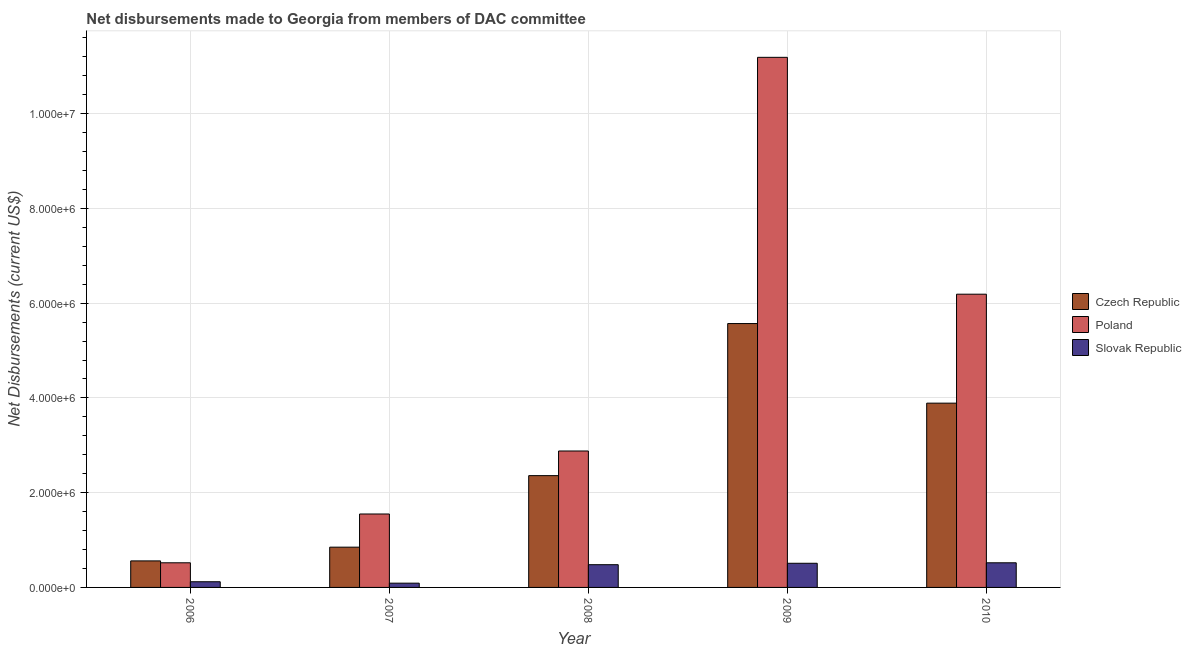How many bars are there on the 2nd tick from the left?
Keep it short and to the point. 3. What is the label of the 2nd group of bars from the left?
Keep it short and to the point. 2007. In how many cases, is the number of bars for a given year not equal to the number of legend labels?
Your answer should be compact. 0. What is the net disbursements made by poland in 2010?
Keep it short and to the point. 6.19e+06. Across all years, what is the maximum net disbursements made by czech republic?
Offer a terse response. 5.57e+06. Across all years, what is the minimum net disbursements made by poland?
Keep it short and to the point. 5.20e+05. What is the total net disbursements made by poland in the graph?
Provide a short and direct response. 2.23e+07. What is the difference between the net disbursements made by slovak republic in 2007 and that in 2009?
Keep it short and to the point. -4.20e+05. What is the difference between the net disbursements made by poland in 2006 and the net disbursements made by slovak republic in 2009?
Ensure brevity in your answer.  -1.07e+07. What is the average net disbursements made by poland per year?
Ensure brevity in your answer.  4.47e+06. In how many years, is the net disbursements made by poland greater than 2400000 US$?
Provide a succinct answer. 3. What is the ratio of the net disbursements made by poland in 2008 to that in 2010?
Give a very brief answer. 0.47. Is the net disbursements made by poland in 2006 less than that in 2010?
Offer a terse response. Yes. What is the difference between the highest and the second highest net disbursements made by czech republic?
Keep it short and to the point. 1.68e+06. What is the difference between the highest and the lowest net disbursements made by czech republic?
Your answer should be compact. 5.01e+06. What does the 3rd bar from the right in 2008 represents?
Provide a short and direct response. Czech Republic. Is it the case that in every year, the sum of the net disbursements made by czech republic and net disbursements made by poland is greater than the net disbursements made by slovak republic?
Your response must be concise. Yes. How many bars are there?
Provide a short and direct response. 15. What is the difference between two consecutive major ticks on the Y-axis?
Ensure brevity in your answer.  2.00e+06. Are the values on the major ticks of Y-axis written in scientific E-notation?
Provide a succinct answer. Yes. Does the graph contain any zero values?
Provide a short and direct response. No. Does the graph contain grids?
Offer a very short reply. Yes. Where does the legend appear in the graph?
Ensure brevity in your answer.  Center right. How many legend labels are there?
Make the answer very short. 3. How are the legend labels stacked?
Offer a terse response. Vertical. What is the title of the graph?
Give a very brief answer. Net disbursements made to Georgia from members of DAC committee. Does "Errors" appear as one of the legend labels in the graph?
Your answer should be very brief. No. What is the label or title of the X-axis?
Keep it short and to the point. Year. What is the label or title of the Y-axis?
Offer a very short reply. Net Disbursements (current US$). What is the Net Disbursements (current US$) of Czech Republic in 2006?
Provide a short and direct response. 5.60e+05. What is the Net Disbursements (current US$) of Poland in 2006?
Give a very brief answer. 5.20e+05. What is the Net Disbursements (current US$) in Slovak Republic in 2006?
Offer a terse response. 1.20e+05. What is the Net Disbursements (current US$) in Czech Republic in 2007?
Provide a succinct answer. 8.50e+05. What is the Net Disbursements (current US$) of Poland in 2007?
Offer a very short reply. 1.55e+06. What is the Net Disbursements (current US$) of Czech Republic in 2008?
Your response must be concise. 2.36e+06. What is the Net Disbursements (current US$) of Poland in 2008?
Provide a succinct answer. 2.88e+06. What is the Net Disbursements (current US$) of Czech Republic in 2009?
Your answer should be compact. 5.57e+06. What is the Net Disbursements (current US$) in Poland in 2009?
Keep it short and to the point. 1.12e+07. What is the Net Disbursements (current US$) of Slovak Republic in 2009?
Give a very brief answer. 5.10e+05. What is the Net Disbursements (current US$) in Czech Republic in 2010?
Give a very brief answer. 3.89e+06. What is the Net Disbursements (current US$) of Poland in 2010?
Give a very brief answer. 6.19e+06. What is the Net Disbursements (current US$) in Slovak Republic in 2010?
Make the answer very short. 5.20e+05. Across all years, what is the maximum Net Disbursements (current US$) of Czech Republic?
Your answer should be compact. 5.57e+06. Across all years, what is the maximum Net Disbursements (current US$) in Poland?
Keep it short and to the point. 1.12e+07. Across all years, what is the maximum Net Disbursements (current US$) in Slovak Republic?
Your answer should be compact. 5.20e+05. Across all years, what is the minimum Net Disbursements (current US$) of Czech Republic?
Offer a very short reply. 5.60e+05. Across all years, what is the minimum Net Disbursements (current US$) in Poland?
Offer a terse response. 5.20e+05. Across all years, what is the minimum Net Disbursements (current US$) of Slovak Republic?
Keep it short and to the point. 9.00e+04. What is the total Net Disbursements (current US$) of Czech Republic in the graph?
Keep it short and to the point. 1.32e+07. What is the total Net Disbursements (current US$) of Poland in the graph?
Offer a terse response. 2.23e+07. What is the total Net Disbursements (current US$) of Slovak Republic in the graph?
Offer a very short reply. 1.72e+06. What is the difference between the Net Disbursements (current US$) of Poland in 2006 and that in 2007?
Your answer should be compact. -1.03e+06. What is the difference between the Net Disbursements (current US$) of Czech Republic in 2006 and that in 2008?
Provide a succinct answer. -1.80e+06. What is the difference between the Net Disbursements (current US$) of Poland in 2006 and that in 2008?
Provide a succinct answer. -2.36e+06. What is the difference between the Net Disbursements (current US$) in Slovak Republic in 2006 and that in 2008?
Provide a succinct answer. -3.60e+05. What is the difference between the Net Disbursements (current US$) of Czech Republic in 2006 and that in 2009?
Your response must be concise. -5.01e+06. What is the difference between the Net Disbursements (current US$) of Poland in 2006 and that in 2009?
Provide a short and direct response. -1.07e+07. What is the difference between the Net Disbursements (current US$) in Slovak Republic in 2006 and that in 2009?
Your answer should be very brief. -3.90e+05. What is the difference between the Net Disbursements (current US$) in Czech Republic in 2006 and that in 2010?
Provide a short and direct response. -3.33e+06. What is the difference between the Net Disbursements (current US$) in Poland in 2006 and that in 2010?
Provide a short and direct response. -5.67e+06. What is the difference between the Net Disbursements (current US$) of Slovak Republic in 2006 and that in 2010?
Offer a very short reply. -4.00e+05. What is the difference between the Net Disbursements (current US$) of Czech Republic in 2007 and that in 2008?
Provide a succinct answer. -1.51e+06. What is the difference between the Net Disbursements (current US$) in Poland in 2007 and that in 2008?
Keep it short and to the point. -1.33e+06. What is the difference between the Net Disbursements (current US$) of Slovak Republic in 2007 and that in 2008?
Your response must be concise. -3.90e+05. What is the difference between the Net Disbursements (current US$) in Czech Republic in 2007 and that in 2009?
Keep it short and to the point. -4.72e+06. What is the difference between the Net Disbursements (current US$) of Poland in 2007 and that in 2009?
Provide a short and direct response. -9.64e+06. What is the difference between the Net Disbursements (current US$) of Slovak Republic in 2007 and that in 2009?
Your answer should be very brief. -4.20e+05. What is the difference between the Net Disbursements (current US$) in Czech Republic in 2007 and that in 2010?
Provide a succinct answer. -3.04e+06. What is the difference between the Net Disbursements (current US$) in Poland in 2007 and that in 2010?
Offer a terse response. -4.64e+06. What is the difference between the Net Disbursements (current US$) in Slovak Republic in 2007 and that in 2010?
Provide a short and direct response. -4.30e+05. What is the difference between the Net Disbursements (current US$) in Czech Republic in 2008 and that in 2009?
Offer a terse response. -3.21e+06. What is the difference between the Net Disbursements (current US$) in Poland in 2008 and that in 2009?
Make the answer very short. -8.31e+06. What is the difference between the Net Disbursements (current US$) of Slovak Republic in 2008 and that in 2009?
Your answer should be compact. -3.00e+04. What is the difference between the Net Disbursements (current US$) in Czech Republic in 2008 and that in 2010?
Your response must be concise. -1.53e+06. What is the difference between the Net Disbursements (current US$) in Poland in 2008 and that in 2010?
Your response must be concise. -3.31e+06. What is the difference between the Net Disbursements (current US$) of Slovak Republic in 2008 and that in 2010?
Offer a very short reply. -4.00e+04. What is the difference between the Net Disbursements (current US$) in Czech Republic in 2009 and that in 2010?
Offer a very short reply. 1.68e+06. What is the difference between the Net Disbursements (current US$) in Slovak Republic in 2009 and that in 2010?
Give a very brief answer. -10000. What is the difference between the Net Disbursements (current US$) of Czech Republic in 2006 and the Net Disbursements (current US$) of Poland in 2007?
Make the answer very short. -9.90e+05. What is the difference between the Net Disbursements (current US$) of Czech Republic in 2006 and the Net Disbursements (current US$) of Slovak Republic in 2007?
Your answer should be compact. 4.70e+05. What is the difference between the Net Disbursements (current US$) of Poland in 2006 and the Net Disbursements (current US$) of Slovak Republic in 2007?
Offer a terse response. 4.30e+05. What is the difference between the Net Disbursements (current US$) of Czech Republic in 2006 and the Net Disbursements (current US$) of Poland in 2008?
Keep it short and to the point. -2.32e+06. What is the difference between the Net Disbursements (current US$) in Czech Republic in 2006 and the Net Disbursements (current US$) in Poland in 2009?
Keep it short and to the point. -1.06e+07. What is the difference between the Net Disbursements (current US$) in Czech Republic in 2006 and the Net Disbursements (current US$) in Slovak Republic in 2009?
Make the answer very short. 5.00e+04. What is the difference between the Net Disbursements (current US$) in Poland in 2006 and the Net Disbursements (current US$) in Slovak Republic in 2009?
Ensure brevity in your answer.  10000. What is the difference between the Net Disbursements (current US$) of Czech Republic in 2006 and the Net Disbursements (current US$) of Poland in 2010?
Your answer should be compact. -5.63e+06. What is the difference between the Net Disbursements (current US$) in Czech Republic in 2007 and the Net Disbursements (current US$) in Poland in 2008?
Provide a succinct answer. -2.03e+06. What is the difference between the Net Disbursements (current US$) in Poland in 2007 and the Net Disbursements (current US$) in Slovak Republic in 2008?
Provide a succinct answer. 1.07e+06. What is the difference between the Net Disbursements (current US$) of Czech Republic in 2007 and the Net Disbursements (current US$) of Poland in 2009?
Keep it short and to the point. -1.03e+07. What is the difference between the Net Disbursements (current US$) in Czech Republic in 2007 and the Net Disbursements (current US$) in Slovak Republic in 2009?
Ensure brevity in your answer.  3.40e+05. What is the difference between the Net Disbursements (current US$) in Poland in 2007 and the Net Disbursements (current US$) in Slovak Republic in 2009?
Provide a succinct answer. 1.04e+06. What is the difference between the Net Disbursements (current US$) in Czech Republic in 2007 and the Net Disbursements (current US$) in Poland in 2010?
Your answer should be compact. -5.34e+06. What is the difference between the Net Disbursements (current US$) in Czech Republic in 2007 and the Net Disbursements (current US$) in Slovak Republic in 2010?
Provide a succinct answer. 3.30e+05. What is the difference between the Net Disbursements (current US$) of Poland in 2007 and the Net Disbursements (current US$) of Slovak Republic in 2010?
Give a very brief answer. 1.03e+06. What is the difference between the Net Disbursements (current US$) of Czech Republic in 2008 and the Net Disbursements (current US$) of Poland in 2009?
Provide a succinct answer. -8.83e+06. What is the difference between the Net Disbursements (current US$) of Czech Republic in 2008 and the Net Disbursements (current US$) of Slovak Republic in 2009?
Your answer should be very brief. 1.85e+06. What is the difference between the Net Disbursements (current US$) of Poland in 2008 and the Net Disbursements (current US$) of Slovak Republic in 2009?
Provide a short and direct response. 2.37e+06. What is the difference between the Net Disbursements (current US$) of Czech Republic in 2008 and the Net Disbursements (current US$) of Poland in 2010?
Your response must be concise. -3.83e+06. What is the difference between the Net Disbursements (current US$) of Czech Republic in 2008 and the Net Disbursements (current US$) of Slovak Republic in 2010?
Ensure brevity in your answer.  1.84e+06. What is the difference between the Net Disbursements (current US$) of Poland in 2008 and the Net Disbursements (current US$) of Slovak Republic in 2010?
Offer a terse response. 2.36e+06. What is the difference between the Net Disbursements (current US$) in Czech Republic in 2009 and the Net Disbursements (current US$) in Poland in 2010?
Provide a short and direct response. -6.20e+05. What is the difference between the Net Disbursements (current US$) of Czech Republic in 2009 and the Net Disbursements (current US$) of Slovak Republic in 2010?
Offer a very short reply. 5.05e+06. What is the difference between the Net Disbursements (current US$) in Poland in 2009 and the Net Disbursements (current US$) in Slovak Republic in 2010?
Keep it short and to the point. 1.07e+07. What is the average Net Disbursements (current US$) of Czech Republic per year?
Offer a very short reply. 2.65e+06. What is the average Net Disbursements (current US$) of Poland per year?
Keep it short and to the point. 4.47e+06. What is the average Net Disbursements (current US$) in Slovak Republic per year?
Provide a succinct answer. 3.44e+05. In the year 2006, what is the difference between the Net Disbursements (current US$) in Czech Republic and Net Disbursements (current US$) in Poland?
Your answer should be very brief. 4.00e+04. In the year 2006, what is the difference between the Net Disbursements (current US$) in Poland and Net Disbursements (current US$) in Slovak Republic?
Make the answer very short. 4.00e+05. In the year 2007, what is the difference between the Net Disbursements (current US$) in Czech Republic and Net Disbursements (current US$) in Poland?
Provide a short and direct response. -7.00e+05. In the year 2007, what is the difference between the Net Disbursements (current US$) in Czech Republic and Net Disbursements (current US$) in Slovak Republic?
Offer a very short reply. 7.60e+05. In the year 2007, what is the difference between the Net Disbursements (current US$) in Poland and Net Disbursements (current US$) in Slovak Republic?
Ensure brevity in your answer.  1.46e+06. In the year 2008, what is the difference between the Net Disbursements (current US$) in Czech Republic and Net Disbursements (current US$) in Poland?
Offer a terse response. -5.20e+05. In the year 2008, what is the difference between the Net Disbursements (current US$) in Czech Republic and Net Disbursements (current US$) in Slovak Republic?
Keep it short and to the point. 1.88e+06. In the year 2008, what is the difference between the Net Disbursements (current US$) in Poland and Net Disbursements (current US$) in Slovak Republic?
Keep it short and to the point. 2.40e+06. In the year 2009, what is the difference between the Net Disbursements (current US$) in Czech Republic and Net Disbursements (current US$) in Poland?
Your response must be concise. -5.62e+06. In the year 2009, what is the difference between the Net Disbursements (current US$) of Czech Republic and Net Disbursements (current US$) of Slovak Republic?
Keep it short and to the point. 5.06e+06. In the year 2009, what is the difference between the Net Disbursements (current US$) of Poland and Net Disbursements (current US$) of Slovak Republic?
Make the answer very short. 1.07e+07. In the year 2010, what is the difference between the Net Disbursements (current US$) in Czech Republic and Net Disbursements (current US$) in Poland?
Your answer should be compact. -2.30e+06. In the year 2010, what is the difference between the Net Disbursements (current US$) of Czech Republic and Net Disbursements (current US$) of Slovak Republic?
Provide a short and direct response. 3.37e+06. In the year 2010, what is the difference between the Net Disbursements (current US$) in Poland and Net Disbursements (current US$) in Slovak Republic?
Your answer should be very brief. 5.67e+06. What is the ratio of the Net Disbursements (current US$) in Czech Republic in 2006 to that in 2007?
Provide a succinct answer. 0.66. What is the ratio of the Net Disbursements (current US$) of Poland in 2006 to that in 2007?
Offer a terse response. 0.34. What is the ratio of the Net Disbursements (current US$) of Czech Republic in 2006 to that in 2008?
Your response must be concise. 0.24. What is the ratio of the Net Disbursements (current US$) in Poland in 2006 to that in 2008?
Provide a succinct answer. 0.18. What is the ratio of the Net Disbursements (current US$) in Czech Republic in 2006 to that in 2009?
Give a very brief answer. 0.1. What is the ratio of the Net Disbursements (current US$) in Poland in 2006 to that in 2009?
Your answer should be compact. 0.05. What is the ratio of the Net Disbursements (current US$) of Slovak Republic in 2006 to that in 2009?
Offer a very short reply. 0.24. What is the ratio of the Net Disbursements (current US$) of Czech Republic in 2006 to that in 2010?
Provide a succinct answer. 0.14. What is the ratio of the Net Disbursements (current US$) of Poland in 2006 to that in 2010?
Offer a terse response. 0.08. What is the ratio of the Net Disbursements (current US$) in Slovak Republic in 2006 to that in 2010?
Keep it short and to the point. 0.23. What is the ratio of the Net Disbursements (current US$) of Czech Republic in 2007 to that in 2008?
Offer a very short reply. 0.36. What is the ratio of the Net Disbursements (current US$) in Poland in 2007 to that in 2008?
Provide a short and direct response. 0.54. What is the ratio of the Net Disbursements (current US$) in Slovak Republic in 2007 to that in 2008?
Your response must be concise. 0.19. What is the ratio of the Net Disbursements (current US$) in Czech Republic in 2007 to that in 2009?
Provide a short and direct response. 0.15. What is the ratio of the Net Disbursements (current US$) in Poland in 2007 to that in 2009?
Provide a succinct answer. 0.14. What is the ratio of the Net Disbursements (current US$) of Slovak Republic in 2007 to that in 2009?
Your answer should be compact. 0.18. What is the ratio of the Net Disbursements (current US$) in Czech Republic in 2007 to that in 2010?
Provide a short and direct response. 0.22. What is the ratio of the Net Disbursements (current US$) in Poland in 2007 to that in 2010?
Your answer should be very brief. 0.25. What is the ratio of the Net Disbursements (current US$) in Slovak Republic in 2007 to that in 2010?
Give a very brief answer. 0.17. What is the ratio of the Net Disbursements (current US$) in Czech Republic in 2008 to that in 2009?
Offer a very short reply. 0.42. What is the ratio of the Net Disbursements (current US$) of Poland in 2008 to that in 2009?
Your answer should be very brief. 0.26. What is the ratio of the Net Disbursements (current US$) of Slovak Republic in 2008 to that in 2009?
Your answer should be compact. 0.94. What is the ratio of the Net Disbursements (current US$) of Czech Republic in 2008 to that in 2010?
Give a very brief answer. 0.61. What is the ratio of the Net Disbursements (current US$) of Poland in 2008 to that in 2010?
Your answer should be compact. 0.47. What is the ratio of the Net Disbursements (current US$) of Czech Republic in 2009 to that in 2010?
Offer a terse response. 1.43. What is the ratio of the Net Disbursements (current US$) in Poland in 2009 to that in 2010?
Offer a terse response. 1.81. What is the ratio of the Net Disbursements (current US$) in Slovak Republic in 2009 to that in 2010?
Your response must be concise. 0.98. What is the difference between the highest and the second highest Net Disbursements (current US$) of Czech Republic?
Ensure brevity in your answer.  1.68e+06. What is the difference between the highest and the second highest Net Disbursements (current US$) in Poland?
Offer a terse response. 5.00e+06. What is the difference between the highest and the second highest Net Disbursements (current US$) of Slovak Republic?
Offer a very short reply. 10000. What is the difference between the highest and the lowest Net Disbursements (current US$) of Czech Republic?
Make the answer very short. 5.01e+06. What is the difference between the highest and the lowest Net Disbursements (current US$) in Poland?
Give a very brief answer. 1.07e+07. 